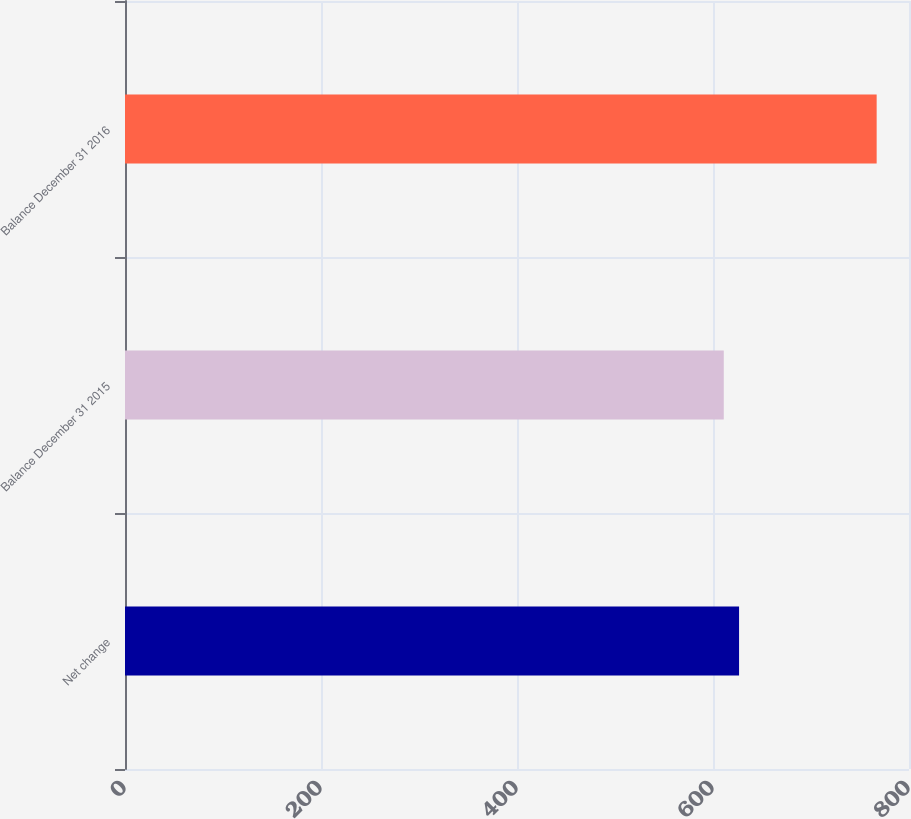<chart> <loc_0><loc_0><loc_500><loc_500><bar_chart><fcel>Net change<fcel>Balance December 31 2015<fcel>Balance December 31 2016<nl><fcel>626.6<fcel>611<fcel>767<nl></chart> 